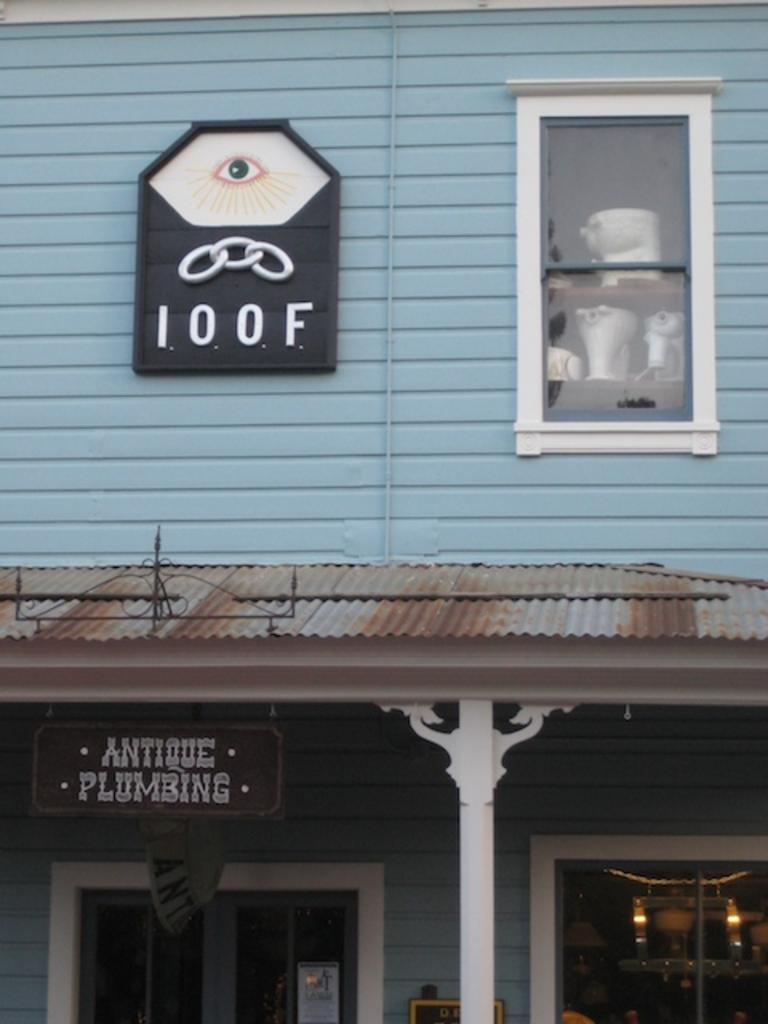<image>
Give a short and clear explanation of the subsequent image. A building that says IOOF and Antique Plumbing on it. 